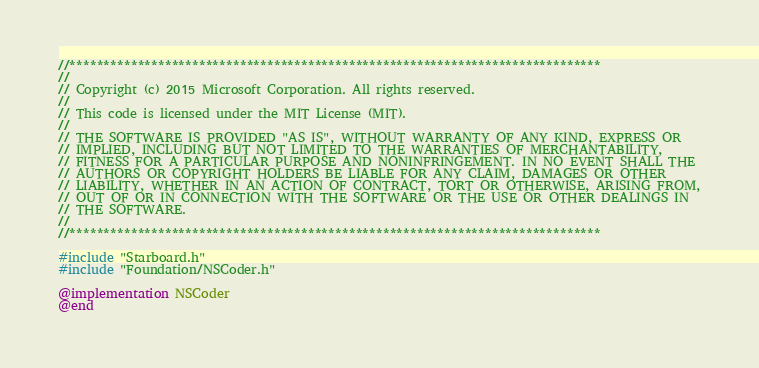Convert code to text. <code><loc_0><loc_0><loc_500><loc_500><_ObjectiveC_>//******************************************************************************
//
// Copyright (c) 2015 Microsoft Corporation. All rights reserved.
//
// This code is licensed under the MIT License (MIT).
//
// THE SOFTWARE IS PROVIDED "AS IS", WITHOUT WARRANTY OF ANY KIND, EXPRESS OR
// IMPLIED, INCLUDING BUT NOT LIMITED TO THE WARRANTIES OF MERCHANTABILITY,
// FITNESS FOR A PARTICULAR PURPOSE AND NONINFRINGEMENT. IN NO EVENT SHALL THE
// AUTHORS OR COPYRIGHT HOLDERS BE LIABLE FOR ANY CLAIM, DAMAGES OR OTHER
// LIABILITY, WHETHER IN AN ACTION OF CONTRACT, TORT OR OTHERWISE, ARISING FROM,
// OUT OF OR IN CONNECTION WITH THE SOFTWARE OR THE USE OR OTHER DEALINGS IN
// THE SOFTWARE.
//
//******************************************************************************

#include "Starboard.h"
#include "Foundation/NSCoder.h"

@implementation NSCoder
@end</code> 